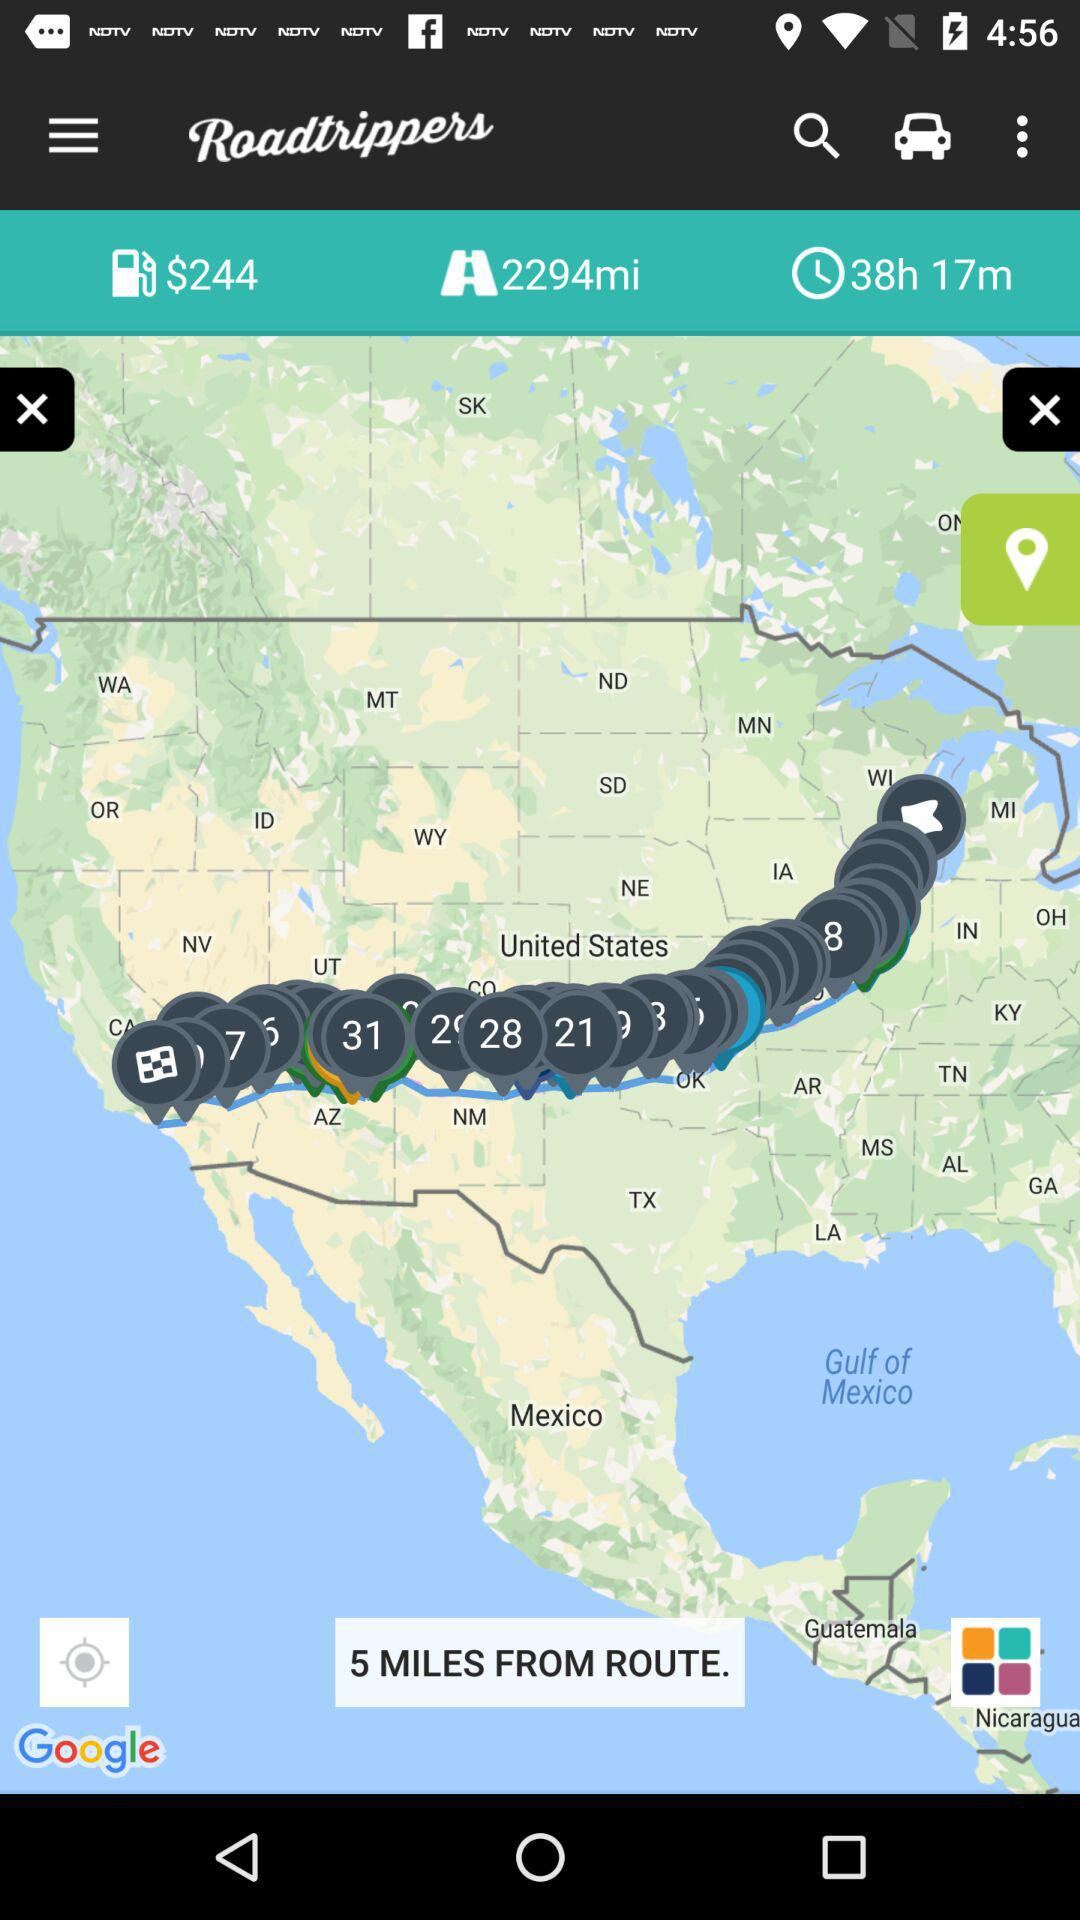What is the distance from the route? The distance is 5 miles. 